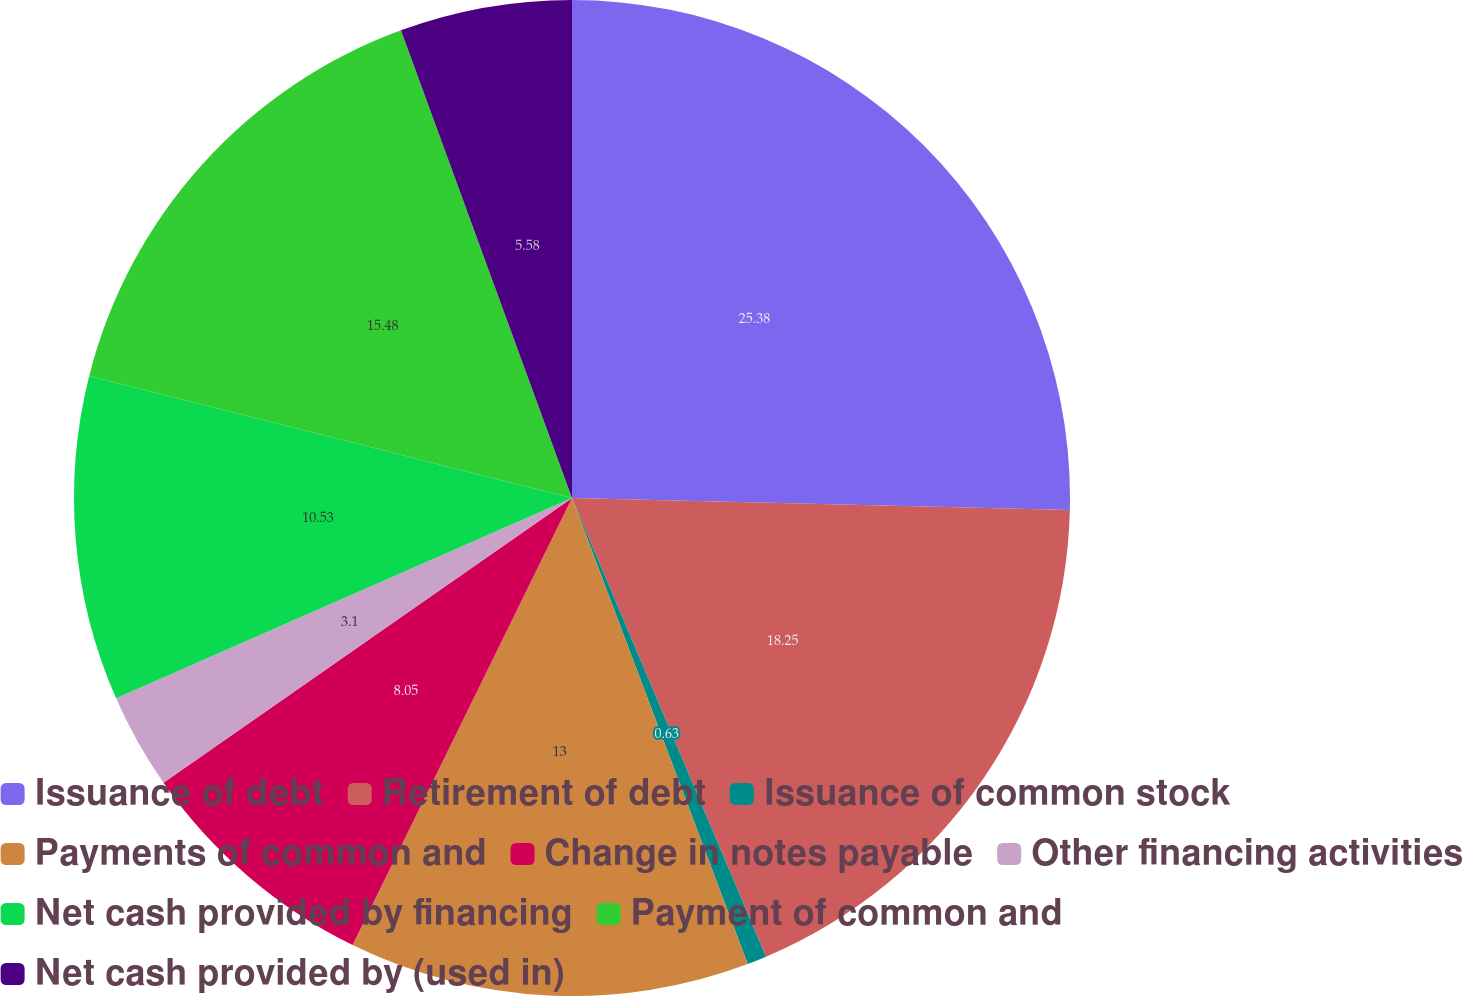<chart> <loc_0><loc_0><loc_500><loc_500><pie_chart><fcel>Issuance of debt<fcel>Retirement of debt<fcel>Issuance of common stock<fcel>Payments of common and<fcel>Change in notes payable<fcel>Other financing activities<fcel>Net cash provided by financing<fcel>Payment of common and<fcel>Net cash provided by (used in)<nl><fcel>25.38%<fcel>18.25%<fcel>0.63%<fcel>13.0%<fcel>8.05%<fcel>3.1%<fcel>10.53%<fcel>15.48%<fcel>5.58%<nl></chart> 